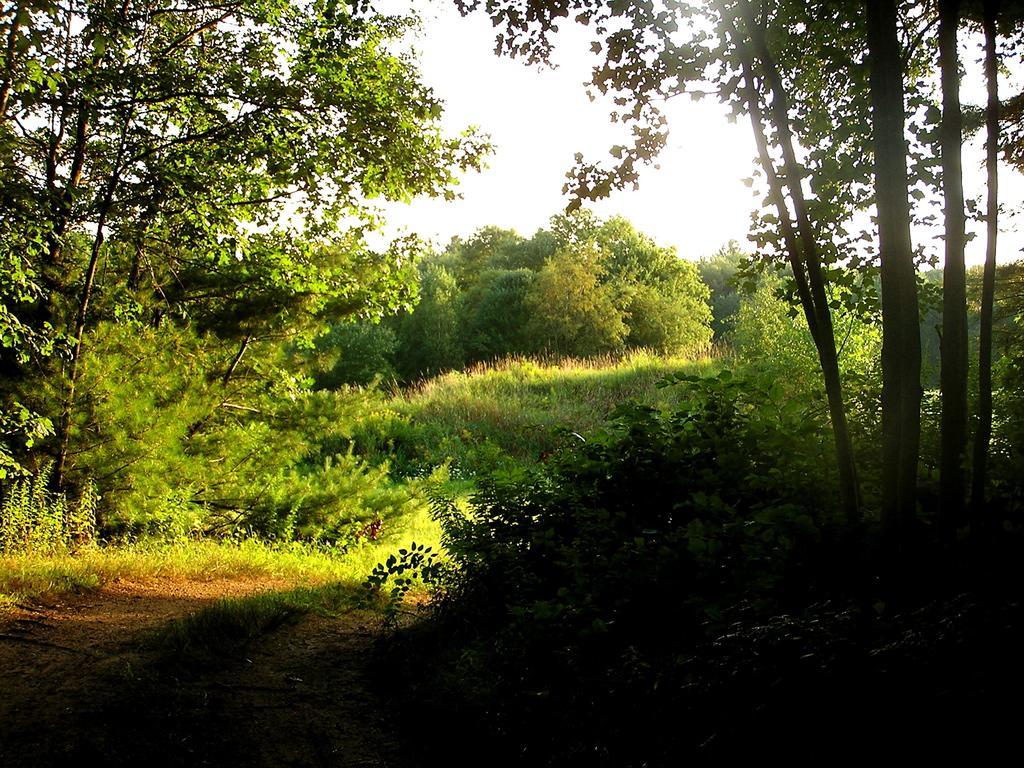Please provide a concise description of this image. In this picture we can see a path and trees. Behind the trees there is a sky. 